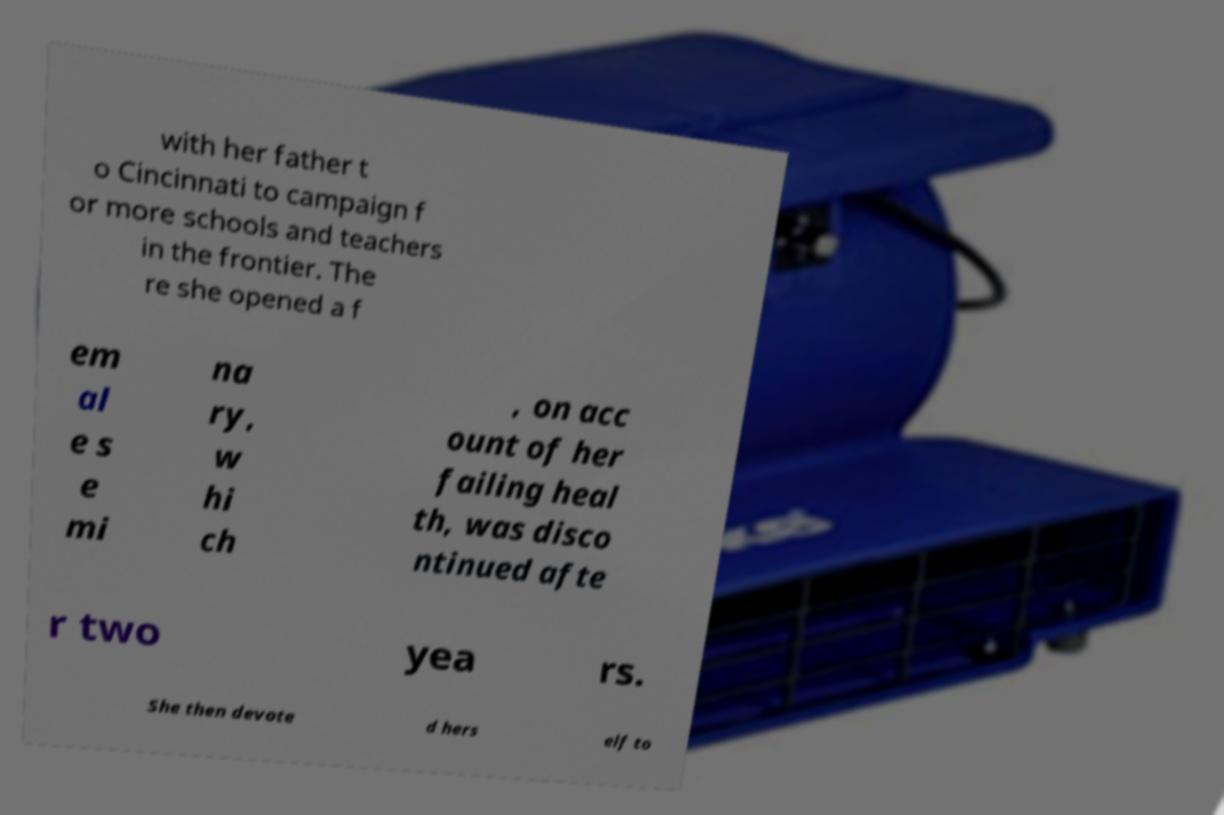Could you extract and type out the text from this image? with her father t o Cincinnati to campaign f or more schools and teachers in the frontier. The re she opened a f em al e s e mi na ry, w hi ch , on acc ount of her failing heal th, was disco ntinued afte r two yea rs. She then devote d hers elf to 